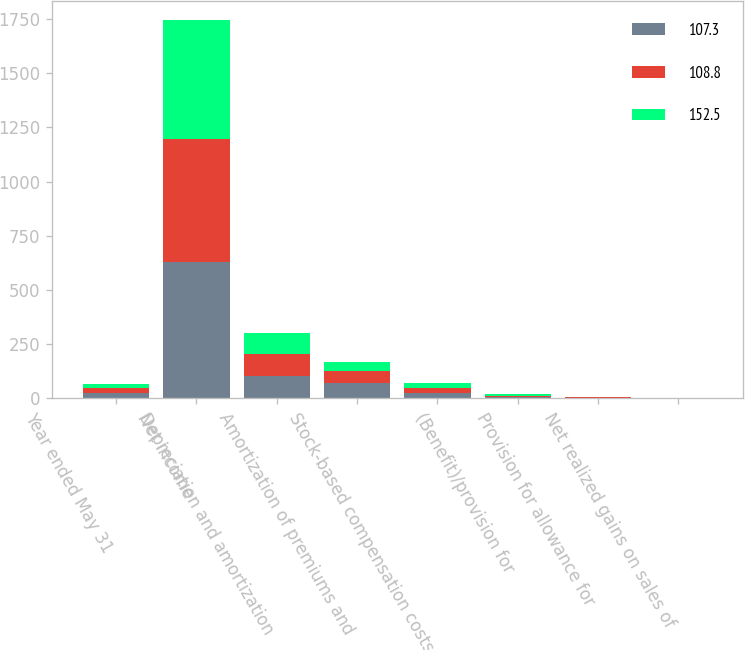Convert chart to OTSL. <chart><loc_0><loc_0><loc_500><loc_500><stacked_bar_chart><ecel><fcel>Year ended May 31<fcel>Net income<fcel>Depreciation and amortization<fcel>Amortization of premiums and<fcel>Stock-based compensation costs<fcel>(Benefit)/provision for<fcel>Provision for allowance for<fcel>Net realized gains on sales of<nl><fcel>107.3<fcel>22.9<fcel>627.5<fcel>105<fcel>70.3<fcel>26.3<fcel>4.9<fcel>2.5<fcel>0.6<nl><fcel>108.8<fcel>22.9<fcel>569<fcel>98.2<fcel>56.2<fcel>22.8<fcel>5.3<fcel>1.7<fcel>0.9<nl><fcel>152.5<fcel>22.9<fcel>548<fcel>97.8<fcel>42.5<fcel>22.9<fcel>11.7<fcel>1.2<fcel>1<nl></chart> 